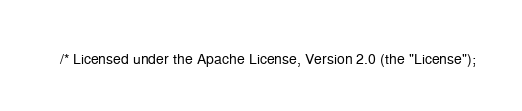Convert code to text. <code><loc_0><loc_0><loc_500><loc_500><_Java_>/* Licensed under the Apache License, Version 2.0 (the "License");</code> 